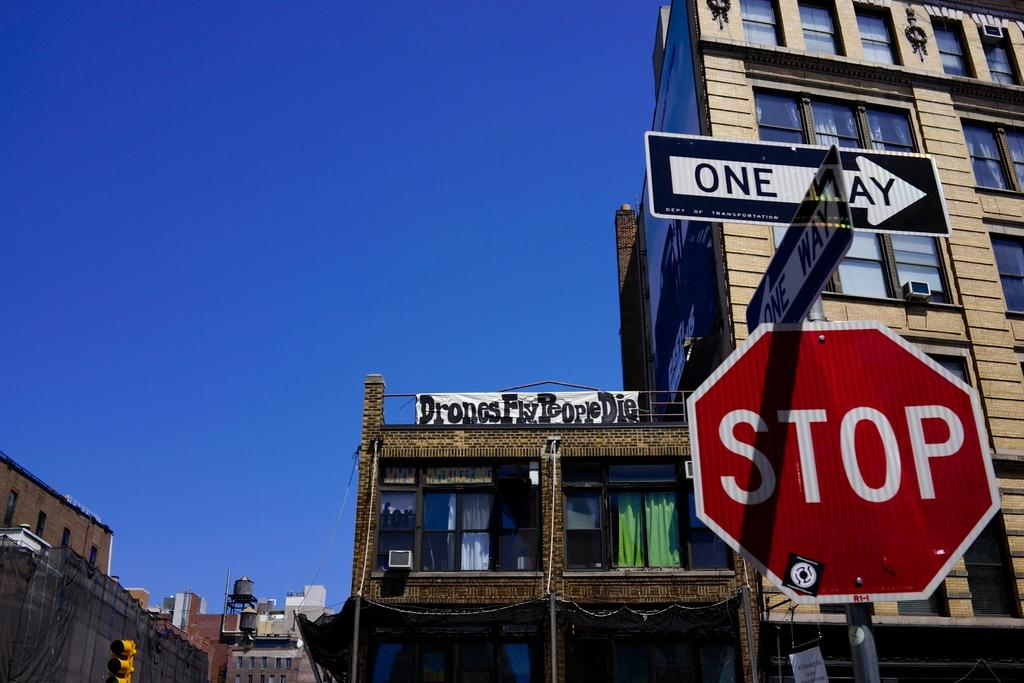<image>
Offer a succinct explanation of the picture presented. A red and white stop sign with a one way sign on top of it. 